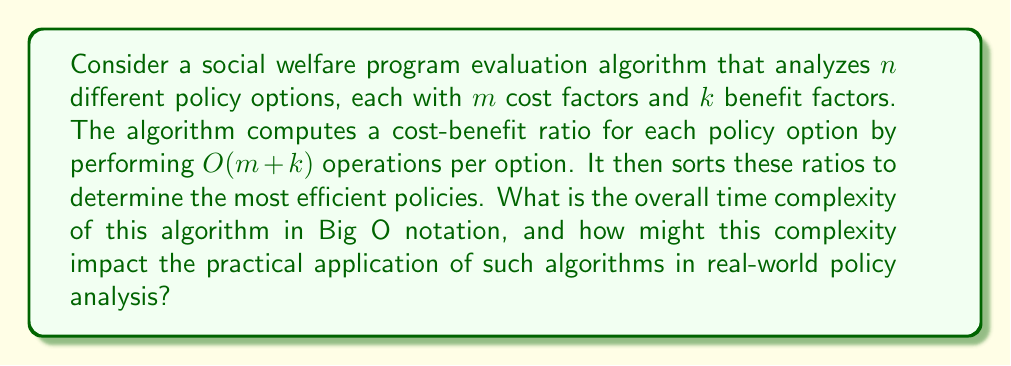Help me with this question. To determine the overall time complexity, let's break down the algorithm into its constituent parts:

1. Analyzing each policy option:
   - There are $n$ policy options
   - For each option, $O(m + k)$ operations are performed
   - Total complexity for this step: $O(n(m + k))$

2. Sorting the cost-benefit ratios:
   - We have $n$ ratios to sort
   - The best comparison-based sorting algorithms have a time complexity of $O(n \log n)$

Therefore, the overall time complexity is:

$$O(n(m + k) + n \log n)$$

We can simplify this expression by considering the dominant terms:

- If $m + k$ is significantly larger than $\log n$, then $O(n(m + k))$ dominates
- If $\log n$ is significantly larger than $m + k$, then $O(n \log n)$ dominates

In practice, the number of cost and benefit factors (m + k) is often relatively small and fixed, while the number of policy options (n) can be large. In this case, we can consider $m + k$ as a constant, simplifying the complexity to:

$$O(n + n \log n) = O(n \log n)$$

This complexity has significant implications for real-world policy analysis:

1. Scalability: As the number of policy options (n) increases, the time required for analysis grows at a rate of $n \log n$. This means that doubling the number of options will slightly more than double the computation time.

2. Practical limitations: For very large datasets (e.g., millions of policy options), the computation time may become prohibitive, potentially limiting the comprehensiveness of the analysis.

3. Trade-offs: Policymakers may need to balance the desire for thorough analysis (considering more options) with the need for timely decision-making.

4. Approximation algorithms: To address computational limitations, analysts might need to consider approximation algorithms or sampling techniques, potentially sacrificing some accuracy for speed.

5. Resource allocation: The complexity underscores the importance of efficient resource allocation in government agencies responsible for policy analysis, as more powerful computing resources may be necessary for comprehensive evaluations.
Answer: The overall time complexity of the algorithm is $O(n \log n)$, where $n$ is the number of policy options being evaluated. This complexity arises from the dominating term of sorting the cost-benefit ratios, assuming the number of cost and benefit factors remains relatively constant as the number of policy options increases. 